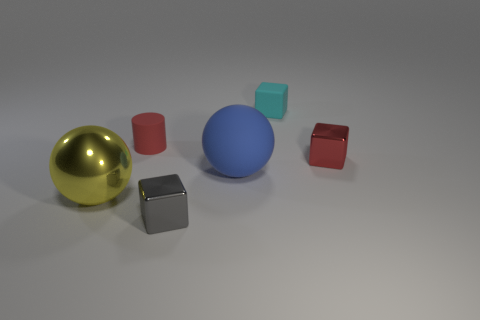There is a block that is the same color as the matte cylinder; what is it made of?
Offer a terse response. Metal. There is a matte thing in front of the tiny rubber object that is in front of the cyan matte thing that is behind the yellow thing; what is its size?
Keep it short and to the point. Large. Are there more tiny cyan rubber things that are behind the blue rubber object than small gray things behind the red metallic object?
Give a very brief answer. Yes. How many small rubber objects are in front of the large sphere on the left side of the tiny gray metal cube?
Offer a very short reply. 0. Are there any rubber spheres of the same color as the small matte cylinder?
Offer a very short reply. No. Is the size of the red rubber object the same as the blue matte thing?
Provide a succinct answer. No. Does the big shiny ball have the same color as the matte cube?
Offer a very short reply. No. There is a small gray cube on the left side of the tiny metallic object right of the small gray metal object; what is it made of?
Offer a very short reply. Metal. There is a tiny red object that is the same shape as the small cyan object; what is it made of?
Keep it short and to the point. Metal. There is a metallic object that is left of the cylinder; is it the same size as the blue rubber object?
Your answer should be very brief. Yes. 